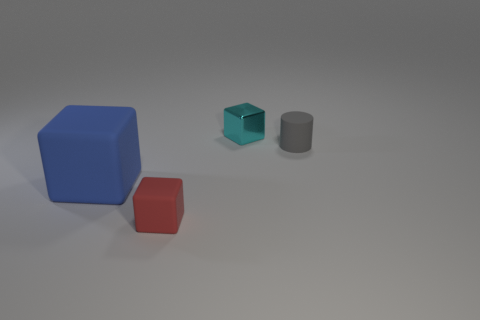Subtract all green cubes. Subtract all blue balls. How many cubes are left? 3 Add 3 tiny cyan shiny cubes. How many objects exist? 7 Subtract all cylinders. How many objects are left? 3 Add 1 red blocks. How many red blocks exist? 2 Subtract 0 blue cylinders. How many objects are left? 4 Subtract all large cyan metal cubes. Subtract all cyan metal things. How many objects are left? 3 Add 3 small red things. How many small red things are left? 4 